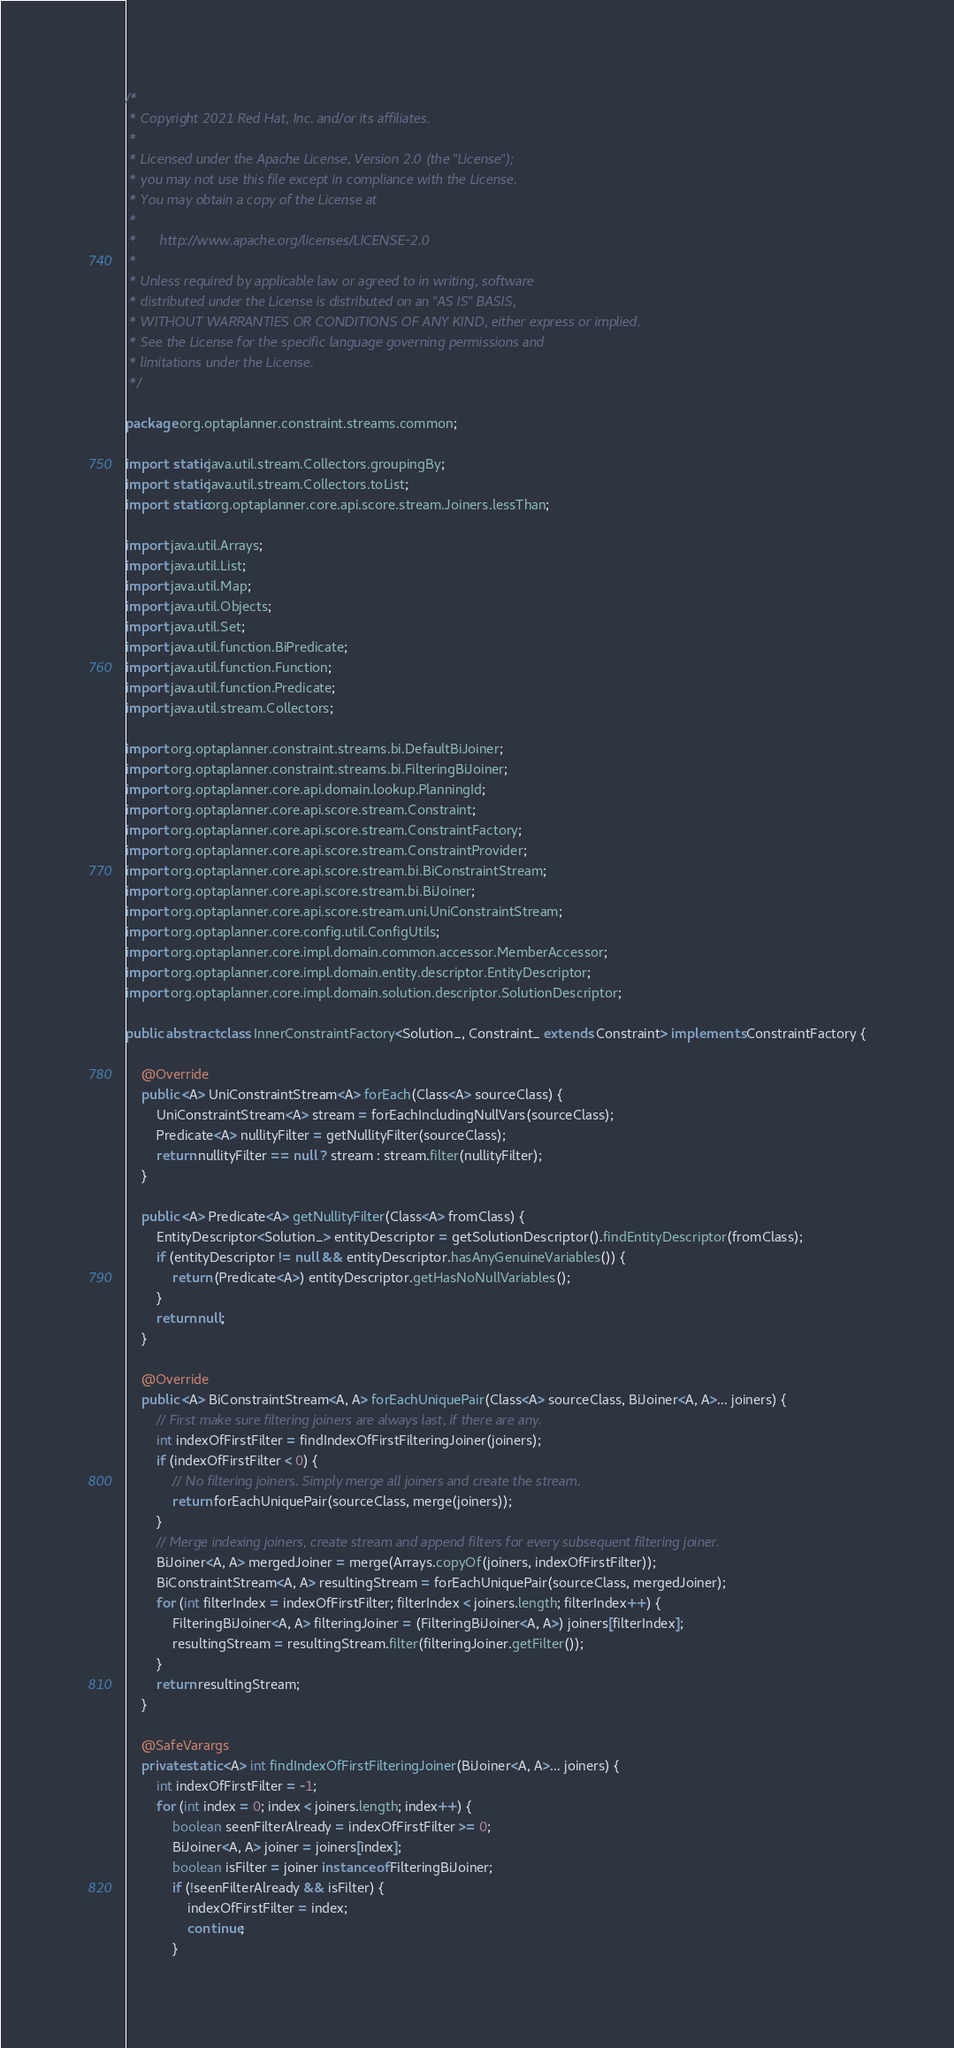<code> <loc_0><loc_0><loc_500><loc_500><_Java_>/*
 * Copyright 2021 Red Hat, Inc. and/or its affiliates.
 *
 * Licensed under the Apache License, Version 2.0 (the "License");
 * you may not use this file except in compliance with the License.
 * You may obtain a copy of the License at
 *
 *      http://www.apache.org/licenses/LICENSE-2.0
 *
 * Unless required by applicable law or agreed to in writing, software
 * distributed under the License is distributed on an "AS IS" BASIS,
 * WITHOUT WARRANTIES OR CONDITIONS OF ANY KIND, either express or implied.
 * See the License for the specific language governing permissions and
 * limitations under the License.
 */

package org.optaplanner.constraint.streams.common;

import static java.util.stream.Collectors.groupingBy;
import static java.util.stream.Collectors.toList;
import static org.optaplanner.core.api.score.stream.Joiners.lessThan;

import java.util.Arrays;
import java.util.List;
import java.util.Map;
import java.util.Objects;
import java.util.Set;
import java.util.function.BiPredicate;
import java.util.function.Function;
import java.util.function.Predicate;
import java.util.stream.Collectors;

import org.optaplanner.constraint.streams.bi.DefaultBiJoiner;
import org.optaplanner.constraint.streams.bi.FilteringBiJoiner;
import org.optaplanner.core.api.domain.lookup.PlanningId;
import org.optaplanner.core.api.score.stream.Constraint;
import org.optaplanner.core.api.score.stream.ConstraintFactory;
import org.optaplanner.core.api.score.stream.ConstraintProvider;
import org.optaplanner.core.api.score.stream.bi.BiConstraintStream;
import org.optaplanner.core.api.score.stream.bi.BiJoiner;
import org.optaplanner.core.api.score.stream.uni.UniConstraintStream;
import org.optaplanner.core.config.util.ConfigUtils;
import org.optaplanner.core.impl.domain.common.accessor.MemberAccessor;
import org.optaplanner.core.impl.domain.entity.descriptor.EntityDescriptor;
import org.optaplanner.core.impl.domain.solution.descriptor.SolutionDescriptor;

public abstract class InnerConstraintFactory<Solution_, Constraint_ extends Constraint> implements ConstraintFactory {

    @Override
    public <A> UniConstraintStream<A> forEach(Class<A> sourceClass) {
        UniConstraintStream<A> stream = forEachIncludingNullVars(sourceClass);
        Predicate<A> nullityFilter = getNullityFilter(sourceClass);
        return nullityFilter == null ? stream : stream.filter(nullityFilter);
    }

    public <A> Predicate<A> getNullityFilter(Class<A> fromClass) {
        EntityDescriptor<Solution_> entityDescriptor = getSolutionDescriptor().findEntityDescriptor(fromClass);
        if (entityDescriptor != null && entityDescriptor.hasAnyGenuineVariables()) {
            return (Predicate<A>) entityDescriptor.getHasNoNullVariables();
        }
        return null;
    }

    @Override
    public <A> BiConstraintStream<A, A> forEachUniquePair(Class<A> sourceClass, BiJoiner<A, A>... joiners) {
        // First make sure filtering joiners are always last, if there are any.
        int indexOfFirstFilter = findIndexOfFirstFilteringJoiner(joiners);
        if (indexOfFirstFilter < 0) {
            // No filtering joiners. Simply merge all joiners and create the stream.
            return forEachUniquePair(sourceClass, merge(joiners));
        }
        // Merge indexing joiners, create stream and append filters for every subsequent filtering joiner.
        BiJoiner<A, A> mergedJoiner = merge(Arrays.copyOf(joiners, indexOfFirstFilter));
        BiConstraintStream<A, A> resultingStream = forEachUniquePair(sourceClass, mergedJoiner);
        for (int filterIndex = indexOfFirstFilter; filterIndex < joiners.length; filterIndex++) {
            FilteringBiJoiner<A, A> filteringJoiner = (FilteringBiJoiner<A, A>) joiners[filterIndex];
            resultingStream = resultingStream.filter(filteringJoiner.getFilter());
        }
        return resultingStream;
    }

    @SafeVarargs
    private static <A> int findIndexOfFirstFilteringJoiner(BiJoiner<A, A>... joiners) {
        int indexOfFirstFilter = -1;
        for (int index = 0; index < joiners.length; index++) {
            boolean seenFilterAlready = indexOfFirstFilter >= 0;
            BiJoiner<A, A> joiner = joiners[index];
            boolean isFilter = joiner instanceof FilteringBiJoiner;
            if (!seenFilterAlready && isFilter) {
                indexOfFirstFilter = index;
                continue;
            }</code> 